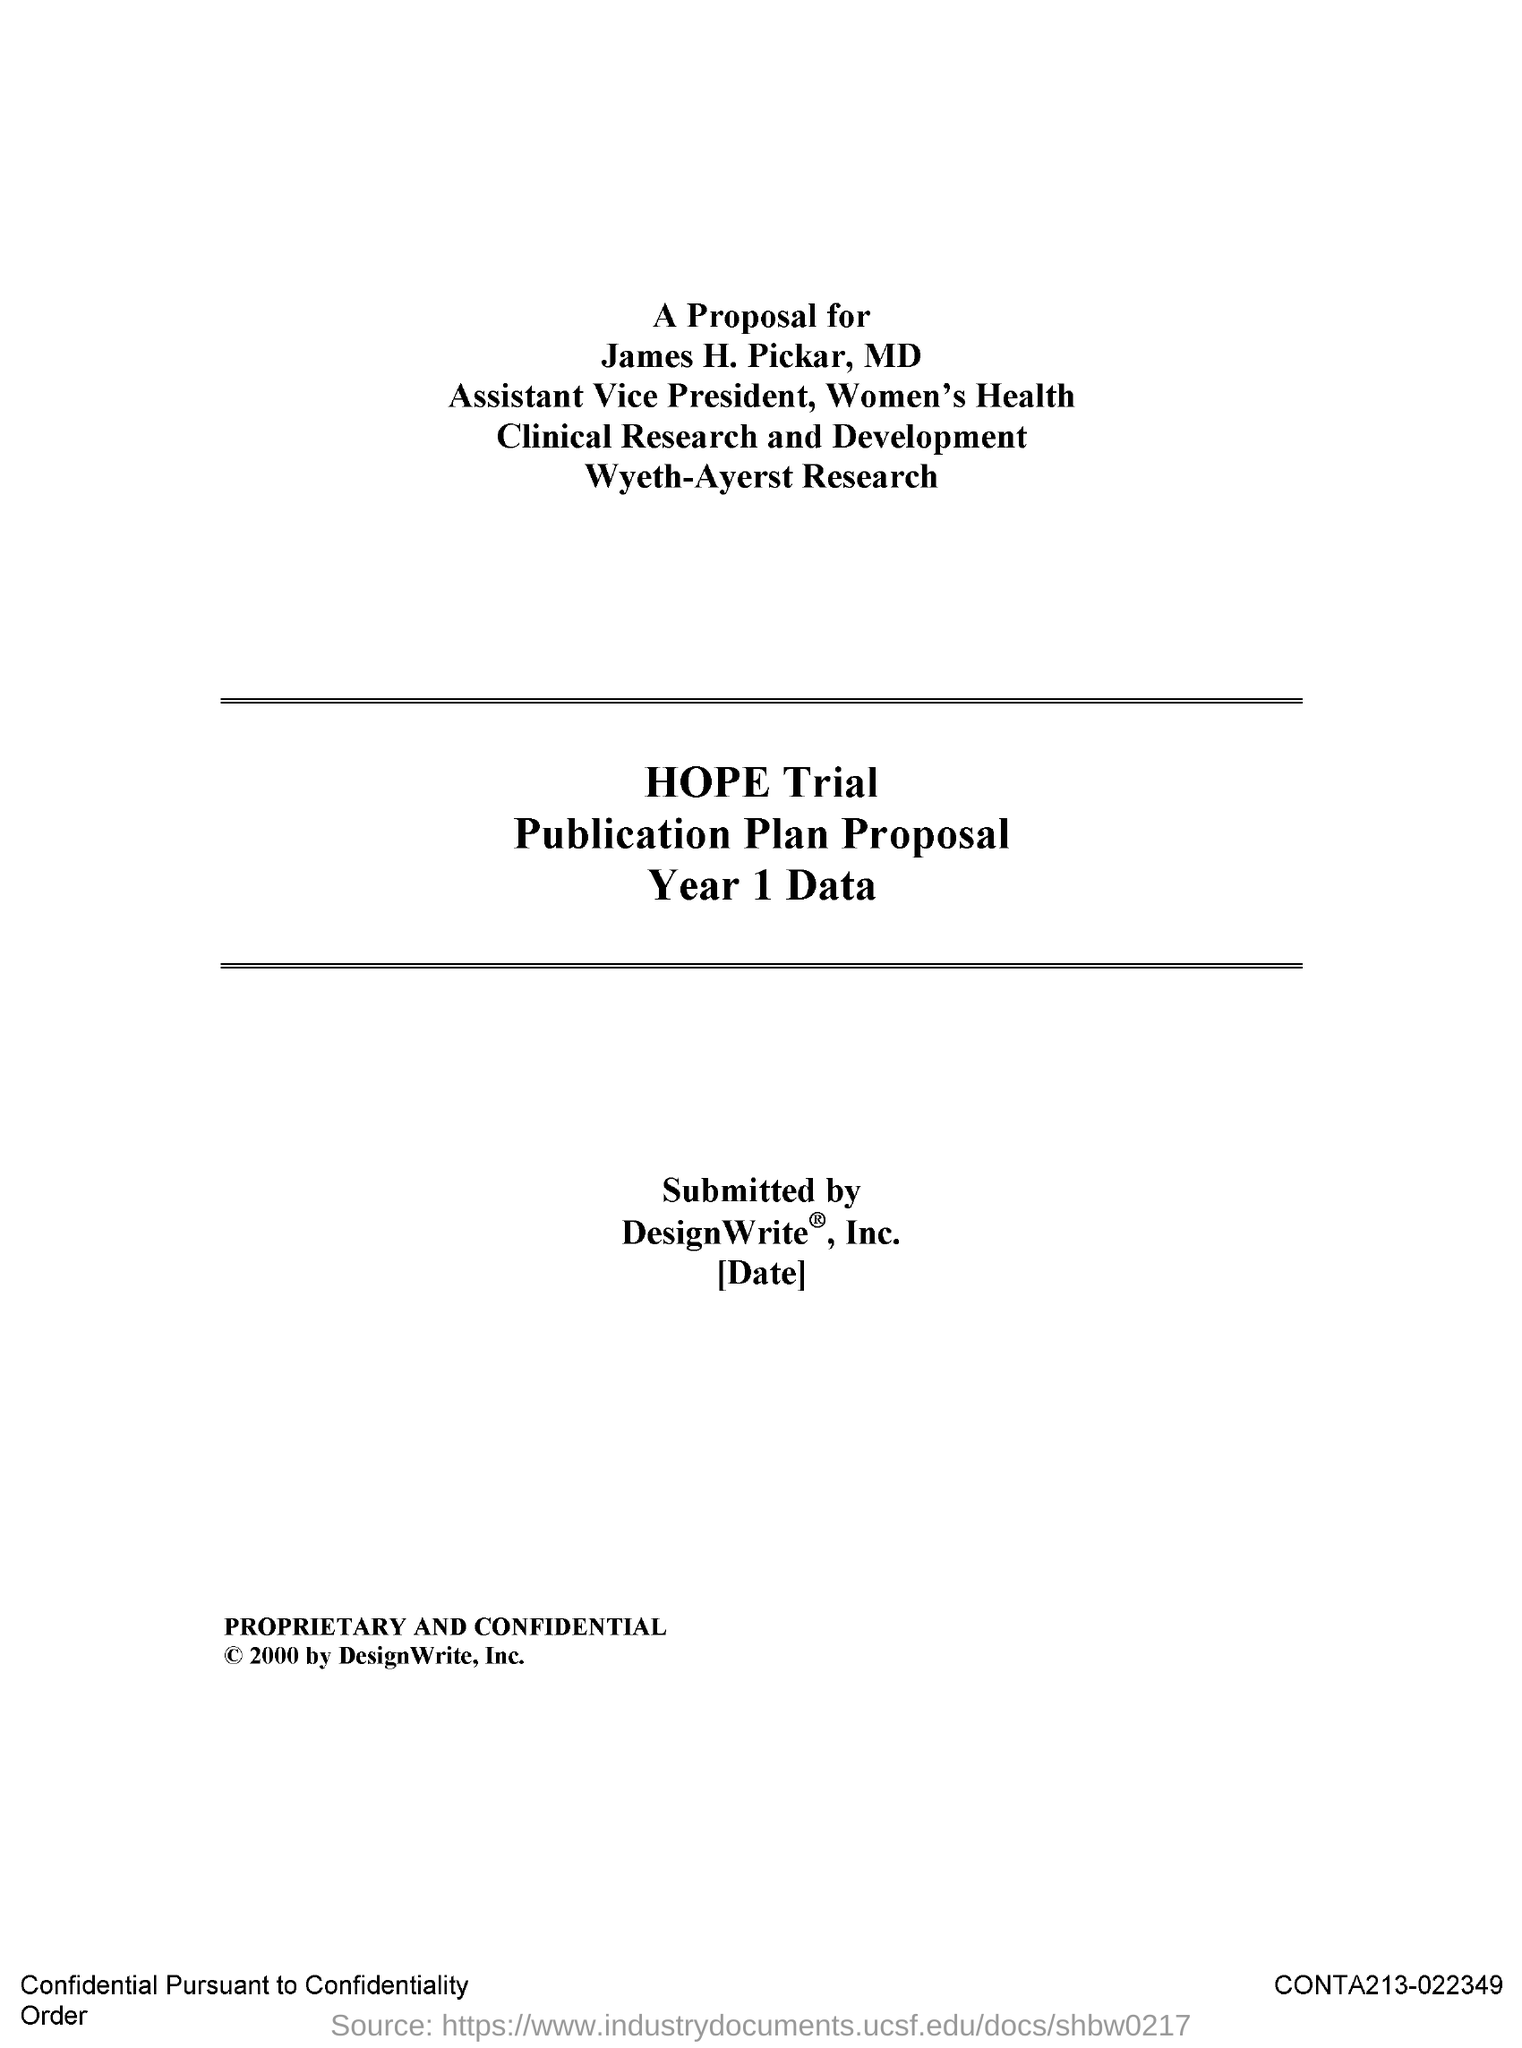Identify some key points in this picture. James H. Pickar is the Assistant Vice President. 